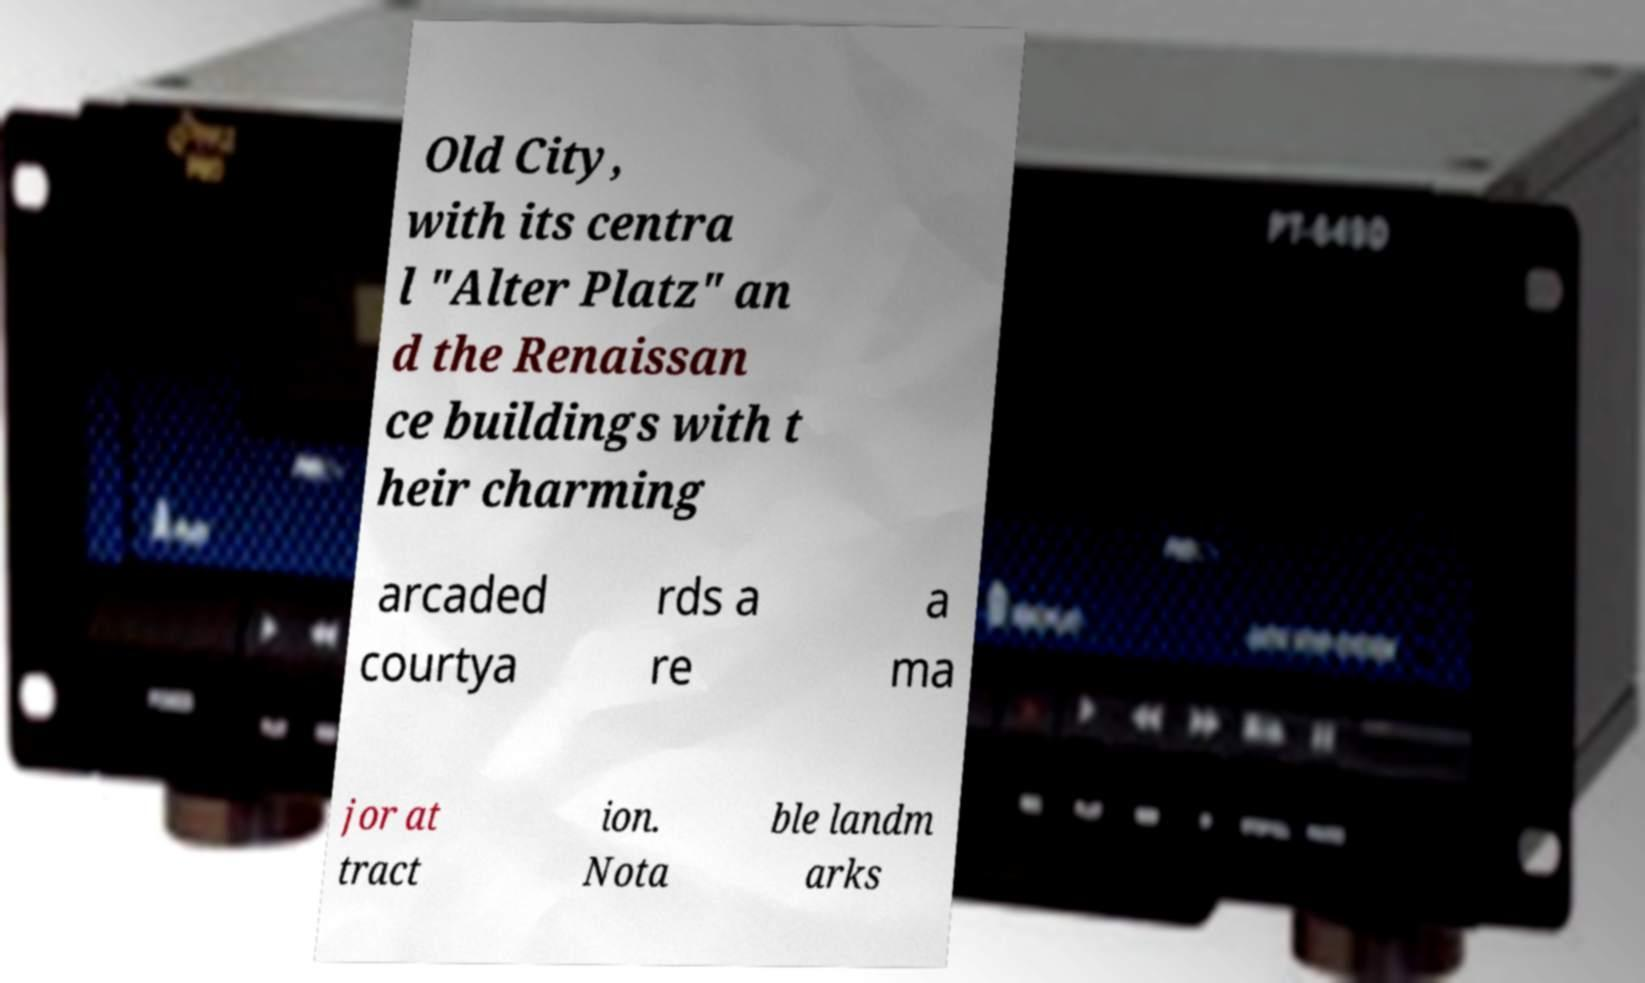What messages or text are displayed in this image? I need them in a readable, typed format. Old City, with its centra l "Alter Platz" an d the Renaissan ce buildings with t heir charming arcaded courtya rds a re a ma jor at tract ion. Nota ble landm arks 